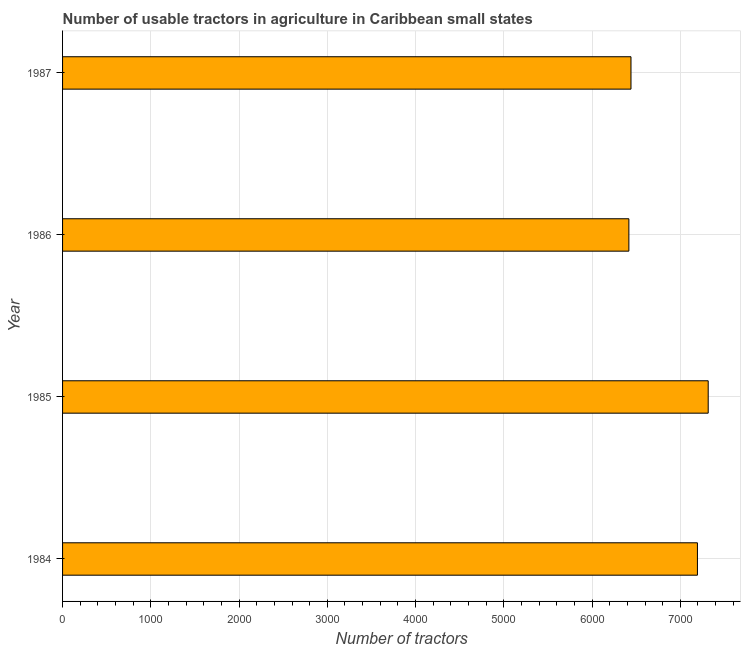Does the graph contain grids?
Provide a short and direct response. Yes. What is the title of the graph?
Ensure brevity in your answer.  Number of usable tractors in agriculture in Caribbean small states. What is the label or title of the X-axis?
Offer a very short reply. Number of tractors. What is the label or title of the Y-axis?
Make the answer very short. Year. What is the number of tractors in 1985?
Your response must be concise. 7316. Across all years, what is the maximum number of tractors?
Your response must be concise. 7316. Across all years, what is the minimum number of tractors?
Offer a very short reply. 6417. In which year was the number of tractors maximum?
Your response must be concise. 1985. In which year was the number of tractors minimum?
Keep it short and to the point. 1986. What is the sum of the number of tractors?
Your response must be concise. 2.74e+04. What is the difference between the number of tractors in 1984 and 1986?
Offer a very short reply. 777. What is the average number of tractors per year?
Give a very brief answer. 6842. What is the median number of tractors?
Your answer should be very brief. 6817.5. In how many years, is the number of tractors greater than 3600 ?
Ensure brevity in your answer.  4. What is the ratio of the number of tractors in 1984 to that in 1987?
Provide a short and direct response. 1.12. Is the number of tractors in 1984 less than that in 1986?
Your answer should be very brief. No. Is the difference between the number of tractors in 1984 and 1985 greater than the difference between any two years?
Keep it short and to the point. No. What is the difference between the highest and the second highest number of tractors?
Offer a very short reply. 122. Is the sum of the number of tractors in 1986 and 1987 greater than the maximum number of tractors across all years?
Offer a very short reply. Yes. What is the difference between the highest and the lowest number of tractors?
Ensure brevity in your answer.  899. In how many years, is the number of tractors greater than the average number of tractors taken over all years?
Provide a succinct answer. 2. What is the Number of tractors in 1984?
Your answer should be very brief. 7194. What is the Number of tractors in 1985?
Give a very brief answer. 7316. What is the Number of tractors in 1986?
Your response must be concise. 6417. What is the Number of tractors in 1987?
Provide a succinct answer. 6441. What is the difference between the Number of tractors in 1984 and 1985?
Offer a terse response. -122. What is the difference between the Number of tractors in 1984 and 1986?
Your answer should be very brief. 777. What is the difference between the Number of tractors in 1984 and 1987?
Provide a succinct answer. 753. What is the difference between the Number of tractors in 1985 and 1986?
Provide a succinct answer. 899. What is the difference between the Number of tractors in 1985 and 1987?
Ensure brevity in your answer.  875. What is the difference between the Number of tractors in 1986 and 1987?
Make the answer very short. -24. What is the ratio of the Number of tractors in 1984 to that in 1986?
Your answer should be very brief. 1.12. What is the ratio of the Number of tractors in 1984 to that in 1987?
Ensure brevity in your answer.  1.12. What is the ratio of the Number of tractors in 1985 to that in 1986?
Ensure brevity in your answer.  1.14. What is the ratio of the Number of tractors in 1985 to that in 1987?
Give a very brief answer. 1.14. What is the ratio of the Number of tractors in 1986 to that in 1987?
Give a very brief answer. 1. 